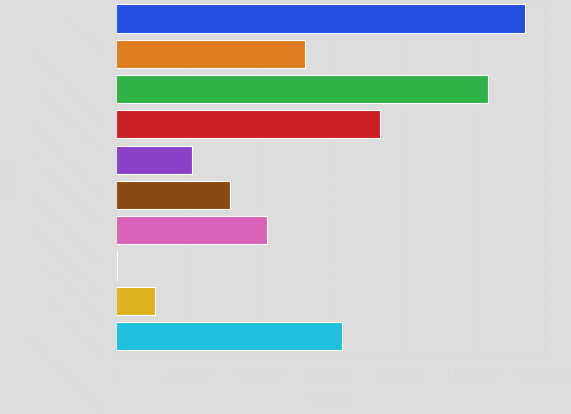<chart> <loc_0><loc_0><loc_500><loc_500><bar_chart><fcel>Segment total<fcel>Elimination of intersegment<fcel>Total HP consolidated net<fcel>Total segment earnings from<fcel>Corporate and unallocated<fcel>Unallocated costs related to<fcel>Amortization of purchased<fcel>In-process research and<fcel>Restructuring charges<fcel>Total HP consolidated earnings<nl><fcel>114838<fcel>52951<fcel>104286<fcel>74055.4<fcel>21294.4<fcel>31846.6<fcel>42398.8<fcel>190<fcel>10742.2<fcel>63503.2<nl></chart> 